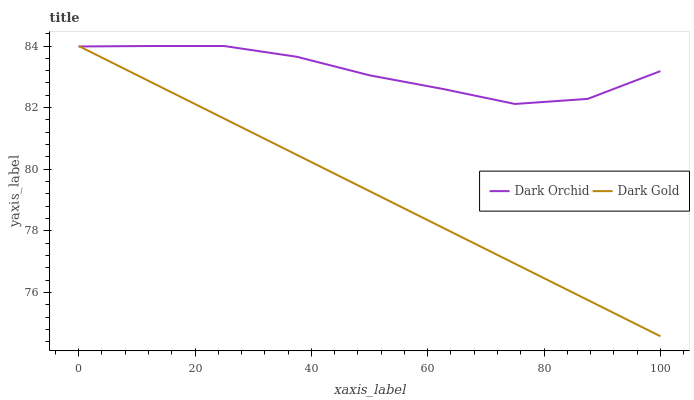Does Dark Gold have the minimum area under the curve?
Answer yes or no. Yes. Does Dark Orchid have the maximum area under the curve?
Answer yes or no. Yes. Does Dark Gold have the maximum area under the curve?
Answer yes or no. No. Is Dark Gold the smoothest?
Answer yes or no. Yes. Is Dark Orchid the roughest?
Answer yes or no. Yes. Is Dark Gold the roughest?
Answer yes or no. No. 